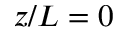<formula> <loc_0><loc_0><loc_500><loc_500>z / L = 0</formula> 